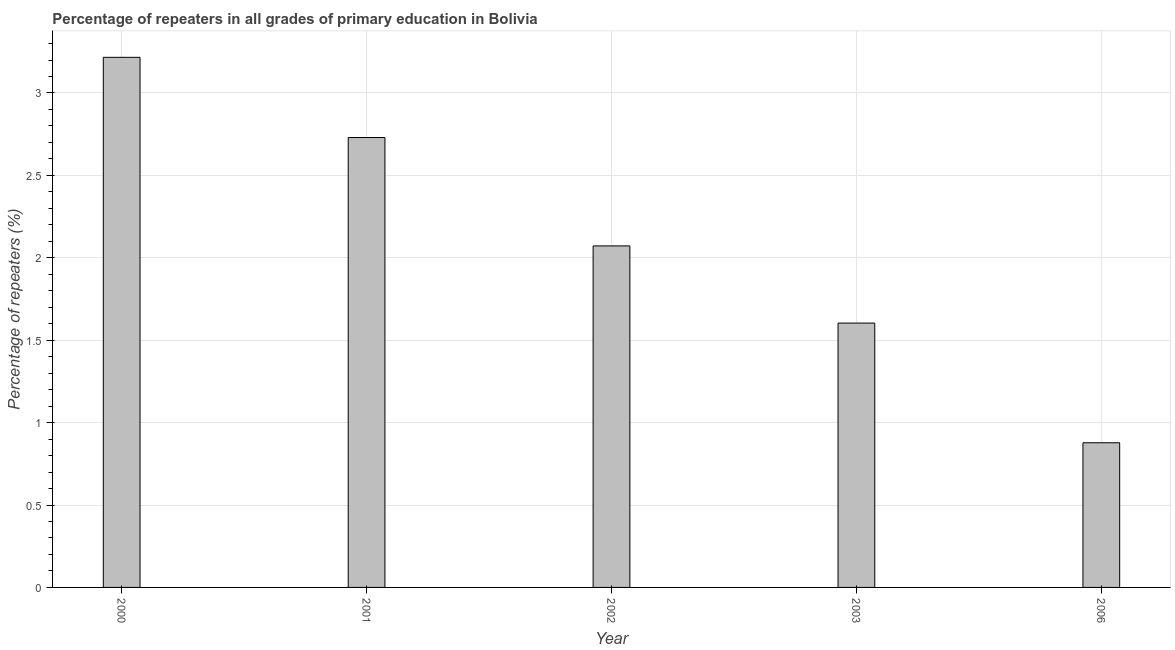What is the title of the graph?
Make the answer very short. Percentage of repeaters in all grades of primary education in Bolivia. What is the label or title of the X-axis?
Keep it short and to the point. Year. What is the label or title of the Y-axis?
Your response must be concise. Percentage of repeaters (%). What is the percentage of repeaters in primary education in 2002?
Make the answer very short. 2.07. Across all years, what is the maximum percentage of repeaters in primary education?
Offer a very short reply. 3.22. Across all years, what is the minimum percentage of repeaters in primary education?
Keep it short and to the point. 0.88. In which year was the percentage of repeaters in primary education minimum?
Offer a terse response. 2006. What is the sum of the percentage of repeaters in primary education?
Keep it short and to the point. 10.5. What is the difference between the percentage of repeaters in primary education in 2000 and 2006?
Ensure brevity in your answer.  2.34. What is the median percentage of repeaters in primary education?
Offer a terse response. 2.07. Do a majority of the years between 2000 and 2006 (inclusive) have percentage of repeaters in primary education greater than 0.9 %?
Provide a succinct answer. Yes. What is the ratio of the percentage of repeaters in primary education in 2000 to that in 2003?
Offer a very short reply. 2. Is the difference between the percentage of repeaters in primary education in 2003 and 2006 greater than the difference between any two years?
Your response must be concise. No. What is the difference between the highest and the second highest percentage of repeaters in primary education?
Keep it short and to the point. 0.49. Is the sum of the percentage of repeaters in primary education in 2000 and 2006 greater than the maximum percentage of repeaters in primary education across all years?
Keep it short and to the point. Yes. What is the difference between the highest and the lowest percentage of repeaters in primary education?
Make the answer very short. 2.34. How many bars are there?
Provide a succinct answer. 5. Are all the bars in the graph horizontal?
Provide a short and direct response. No. How many years are there in the graph?
Keep it short and to the point. 5. What is the Percentage of repeaters (%) in 2000?
Make the answer very short. 3.22. What is the Percentage of repeaters (%) of 2001?
Give a very brief answer. 2.73. What is the Percentage of repeaters (%) of 2002?
Your response must be concise. 2.07. What is the Percentage of repeaters (%) of 2003?
Your answer should be compact. 1.6. What is the Percentage of repeaters (%) of 2006?
Offer a very short reply. 0.88. What is the difference between the Percentage of repeaters (%) in 2000 and 2001?
Give a very brief answer. 0.49. What is the difference between the Percentage of repeaters (%) in 2000 and 2002?
Give a very brief answer. 1.14. What is the difference between the Percentage of repeaters (%) in 2000 and 2003?
Offer a terse response. 1.61. What is the difference between the Percentage of repeaters (%) in 2000 and 2006?
Offer a terse response. 2.34. What is the difference between the Percentage of repeaters (%) in 2001 and 2002?
Keep it short and to the point. 0.66. What is the difference between the Percentage of repeaters (%) in 2001 and 2003?
Make the answer very short. 1.13. What is the difference between the Percentage of repeaters (%) in 2001 and 2006?
Your answer should be very brief. 1.85. What is the difference between the Percentage of repeaters (%) in 2002 and 2003?
Make the answer very short. 0.47. What is the difference between the Percentage of repeaters (%) in 2002 and 2006?
Your response must be concise. 1.19. What is the difference between the Percentage of repeaters (%) in 2003 and 2006?
Your response must be concise. 0.73. What is the ratio of the Percentage of repeaters (%) in 2000 to that in 2001?
Your answer should be very brief. 1.18. What is the ratio of the Percentage of repeaters (%) in 2000 to that in 2002?
Offer a terse response. 1.55. What is the ratio of the Percentage of repeaters (%) in 2000 to that in 2003?
Provide a short and direct response. 2. What is the ratio of the Percentage of repeaters (%) in 2000 to that in 2006?
Give a very brief answer. 3.66. What is the ratio of the Percentage of repeaters (%) in 2001 to that in 2002?
Offer a very short reply. 1.32. What is the ratio of the Percentage of repeaters (%) in 2001 to that in 2003?
Offer a terse response. 1.7. What is the ratio of the Percentage of repeaters (%) in 2001 to that in 2006?
Give a very brief answer. 3.11. What is the ratio of the Percentage of repeaters (%) in 2002 to that in 2003?
Give a very brief answer. 1.29. What is the ratio of the Percentage of repeaters (%) in 2002 to that in 2006?
Provide a succinct answer. 2.36. What is the ratio of the Percentage of repeaters (%) in 2003 to that in 2006?
Offer a very short reply. 1.83. 